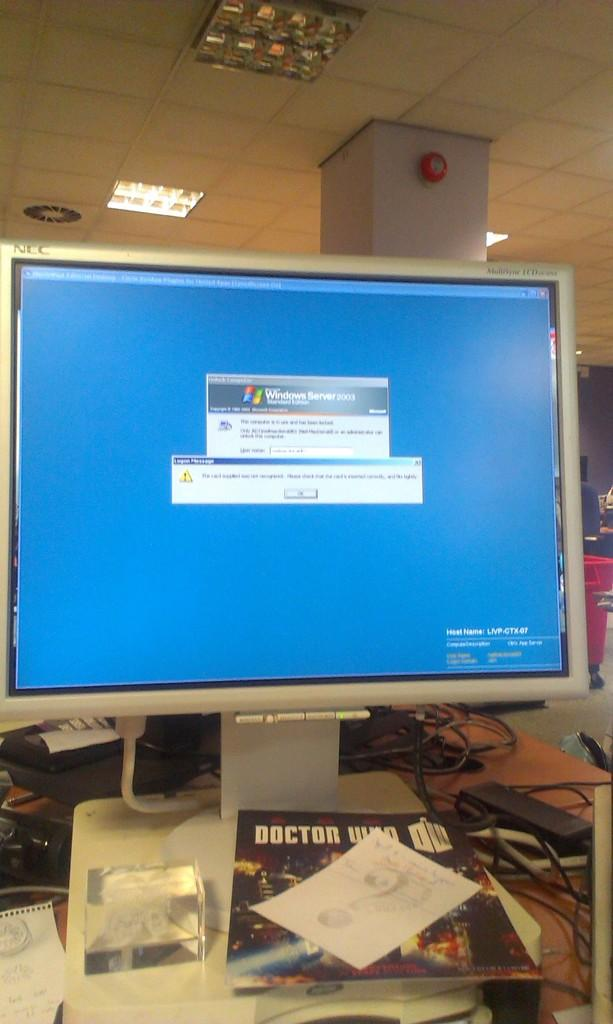<image>
Offer a succinct explanation of the picture presented. A popup window shows the Windows logo with a blue background. 